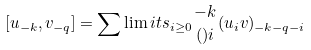Convert formula to latex. <formula><loc_0><loc_0><loc_500><loc_500>[ u _ { - k } , v _ { - q } ] = \sum \lim i t s _ { i \geq 0 } { { - k } \atop ( ) i } ( u _ { i } v ) _ { - k - q - i }</formula> 